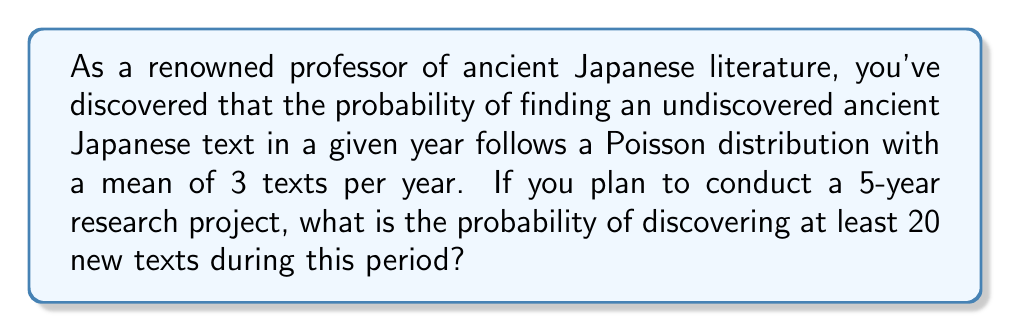Teach me how to tackle this problem. Let's approach this step-by-step:

1) The Poisson distribution models the number of events occurring in a fixed interval of time or space, given a known average rate.

2) In this case, we have:
   - Mean (λ) = 3 texts per year
   - Time period (t) = 5 years
   - We want to find P(X ≥ 20), where X is the number of texts discovered

3) For a 5-year period, the mean number of discoveries becomes:
   λ' = λ * t = 3 * 5 = 15

4) We need to calculate P(X ≥ 20) = 1 - P(X < 20) = 1 - P(X ≤ 19)

5) The cumulative probability function for a Poisson distribution is:

   $$P(X \leq k) = e^{-\lambda'} \sum_{i=0}^k \frac{(\lambda')^i}{i!}$$

6) Calculating P(X ≤ 19) directly would be tedious, so we can use the complementary cumulative distribution function of the Poisson distribution:

   $$P(X > k) = 1 - P(X \leq k) = e^{-\lambda'} \sum_{i=k+1}^{\infty} \frac{(\lambda')^i}{i!}$$

7) Many statistical software packages or calculators can compute this for us. Using such a tool, we find:

   P(X ≥ 20) ≈ 0.1246

8) This can be interpreted as approximately a 12.46% chance of discovering at least 20 new texts during the 5-year project.
Answer: 0.1246 